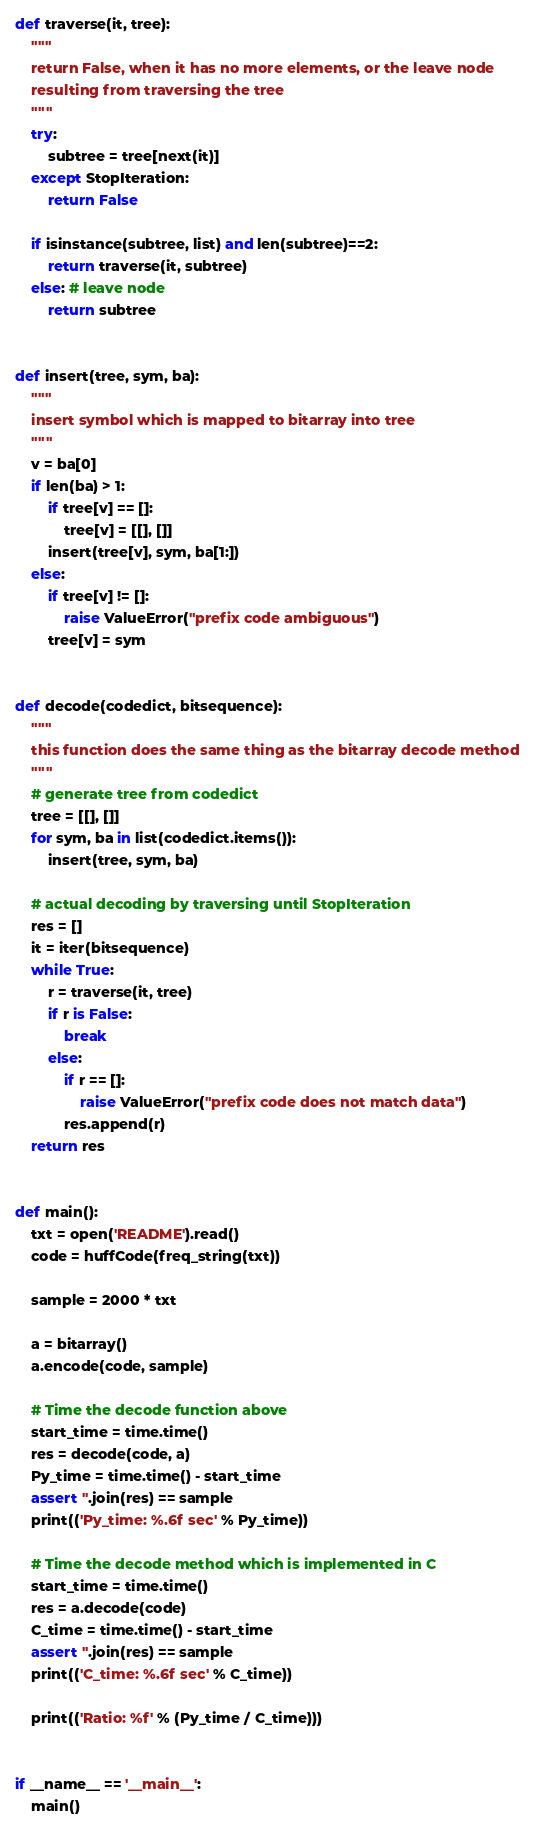Convert code to text. <code><loc_0><loc_0><loc_500><loc_500><_Python_>
def traverse(it, tree):
    """
    return False, when it has no more elements, or the leave node
    resulting from traversing the tree
    """
    try:
        subtree = tree[next(it)]
    except StopIteration:
        return False

    if isinstance(subtree, list) and len(subtree)==2:
        return traverse(it, subtree)
    else: # leave node
        return subtree


def insert(tree, sym, ba):
    """
    insert symbol which is mapped to bitarray into tree
    """
    v = ba[0]
    if len(ba) > 1:
        if tree[v] == []:
            tree[v] = [[], []]
        insert(tree[v], sym, ba[1:])
    else:
        if tree[v] != []:
            raise ValueError("prefix code ambiguous")
        tree[v] = sym


def decode(codedict, bitsequence):
    """
    this function does the same thing as the bitarray decode method
    """
    # generate tree from codedict
    tree = [[], []]
    for sym, ba in list(codedict.items()):
        insert(tree, sym, ba)

    # actual decoding by traversing until StopIteration
    res = []
    it = iter(bitsequence)
    while True:
        r = traverse(it, tree)
        if r is False:
            break
        else:
            if r == []:
                raise ValueError("prefix code does not match data")
            res.append(r)
    return res


def main():
    txt = open('README').read()
    code = huffCode(freq_string(txt))

    sample = 2000 * txt

    a = bitarray()
    a.encode(code, sample)

    # Time the decode function above
    start_time = time.time()
    res = decode(code, a)
    Py_time = time.time() - start_time
    assert ''.join(res) == sample
    print(('Py_time: %.6f sec' % Py_time))

    # Time the decode method which is implemented in C
    start_time = time.time()
    res = a.decode(code)
    C_time = time.time() - start_time
    assert ''.join(res) == sample
    print(('C_time: %.6f sec' % C_time))

    print(('Ratio: %f' % (Py_time / C_time)))


if __name__ == '__main__':
    main()
</code> 